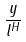<formula> <loc_0><loc_0><loc_500><loc_500>\frac { y } { { l } ^ { H } }</formula> 